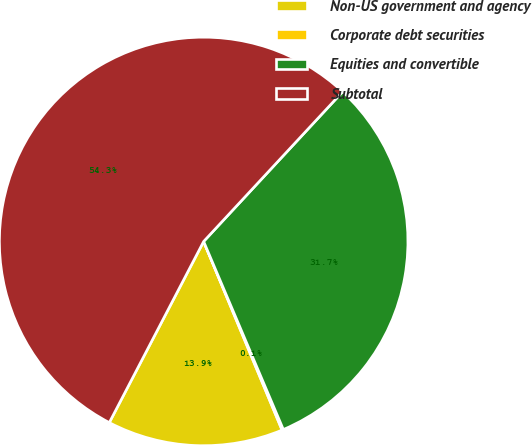<chart> <loc_0><loc_0><loc_500><loc_500><pie_chart><fcel>Non-US government and agency<fcel>Corporate debt securities<fcel>Equities and convertible<fcel>Subtotal<nl><fcel>13.91%<fcel>0.11%<fcel>31.71%<fcel>54.26%<nl></chart> 